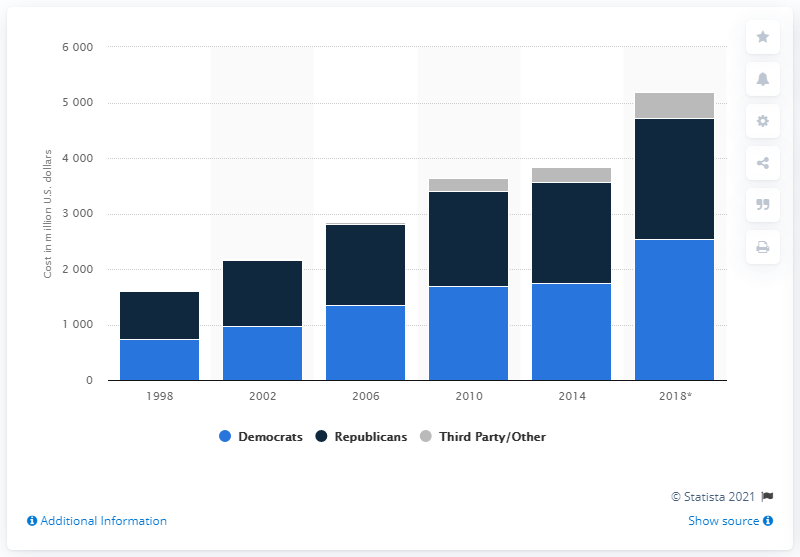Give some essential details in this illustration. In the 2018 midterm elections, third party candidates spent a total of $460.34. According to projections, the Democratic Party is expected to spend approximately 2.5 billion U.S. dollars in the upcoming election. 